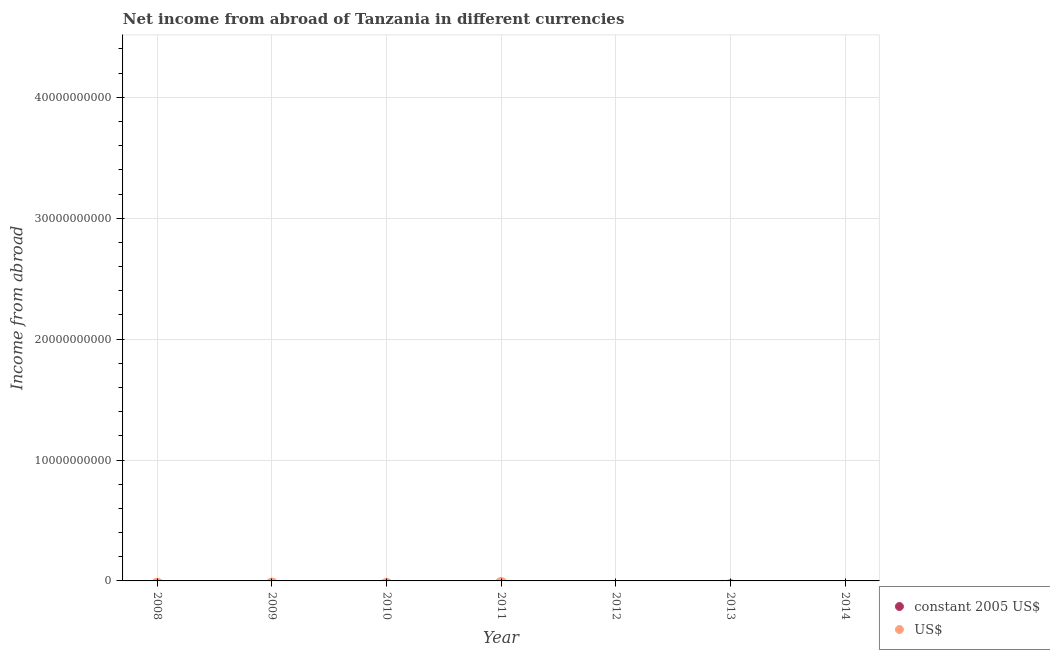What is the income from abroad in constant 2005 us$ in 2010?
Ensure brevity in your answer.  0. Across all years, what is the minimum income from abroad in constant 2005 us$?
Make the answer very short. 0. What is the total income from abroad in us$ in the graph?
Provide a succinct answer. 0. In how many years, is the income from abroad in constant 2005 us$ greater than 10000000000 units?
Give a very brief answer. 0. In how many years, is the income from abroad in us$ greater than the average income from abroad in us$ taken over all years?
Offer a terse response. 0. Does the income from abroad in us$ monotonically increase over the years?
Provide a short and direct response. No. Is the income from abroad in constant 2005 us$ strictly greater than the income from abroad in us$ over the years?
Keep it short and to the point. No. Is the income from abroad in constant 2005 us$ strictly less than the income from abroad in us$ over the years?
Keep it short and to the point. Yes. Where does the legend appear in the graph?
Your answer should be compact. Bottom right. How many legend labels are there?
Give a very brief answer. 2. What is the title of the graph?
Offer a terse response. Net income from abroad of Tanzania in different currencies. What is the label or title of the Y-axis?
Ensure brevity in your answer.  Income from abroad. What is the Income from abroad of constant 2005 US$ in 2011?
Provide a succinct answer. 0. What is the Income from abroad of US$ in 2013?
Provide a succinct answer. 0. What is the Income from abroad in constant 2005 US$ in 2014?
Offer a terse response. 0. What is the Income from abroad in US$ in 2014?
Offer a very short reply. 0. What is the average Income from abroad in constant 2005 US$ per year?
Your answer should be compact. 0. 